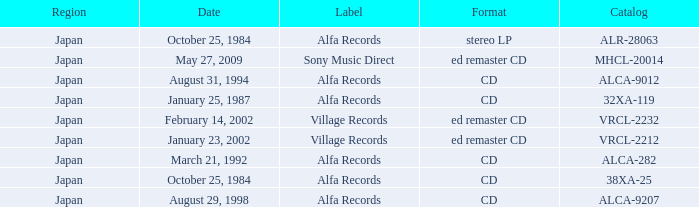What is the region of the release of a CD with catalog 32xa-119? Japan. 